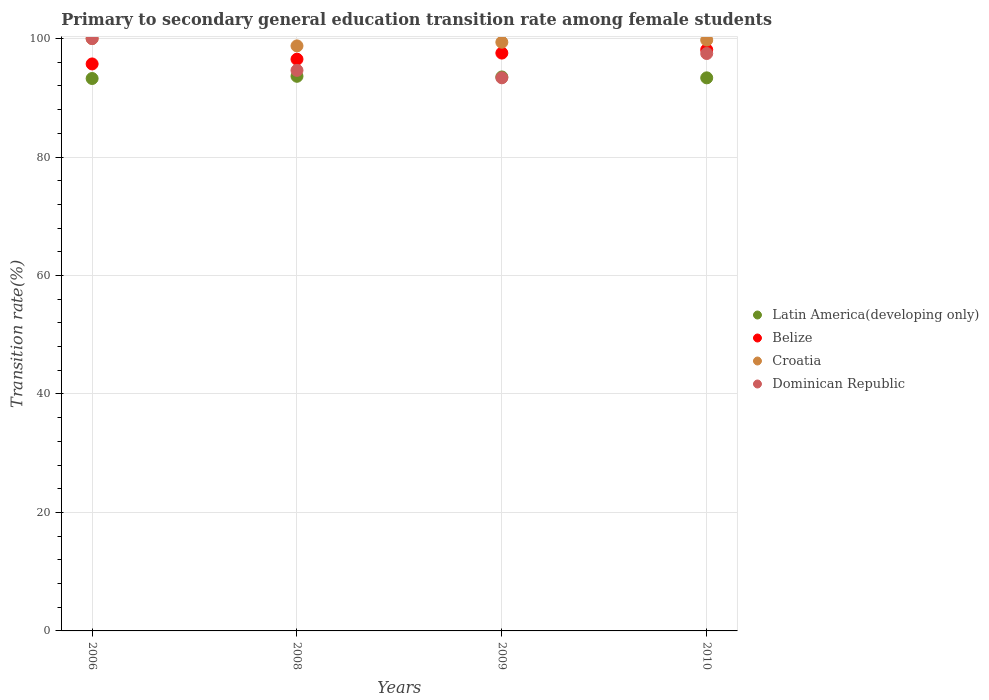What is the transition rate in Croatia in 2010?
Give a very brief answer. 99.75. Across all years, what is the maximum transition rate in Croatia?
Your answer should be compact. 100. Across all years, what is the minimum transition rate in Dominican Republic?
Give a very brief answer. 93.38. In which year was the transition rate in Dominican Republic minimum?
Your answer should be very brief. 2009. What is the total transition rate in Belize in the graph?
Offer a terse response. 387.91. What is the difference between the transition rate in Belize in 2006 and that in 2008?
Provide a succinct answer. -0.8. What is the difference between the transition rate in Dominican Republic in 2006 and the transition rate in Belize in 2008?
Provide a succinct answer. 3.48. What is the average transition rate in Belize per year?
Your answer should be compact. 96.98. In the year 2010, what is the difference between the transition rate in Latin America(developing only) and transition rate in Croatia?
Give a very brief answer. -6.38. What is the ratio of the transition rate in Latin America(developing only) in 2006 to that in 2010?
Keep it short and to the point. 1. Is the difference between the transition rate in Latin America(developing only) in 2006 and 2009 greater than the difference between the transition rate in Croatia in 2006 and 2009?
Provide a short and direct response. No. What is the difference between the highest and the second highest transition rate in Croatia?
Give a very brief answer. 0.25. What is the difference between the highest and the lowest transition rate in Croatia?
Make the answer very short. 1.23. In how many years, is the transition rate in Croatia greater than the average transition rate in Croatia taken over all years?
Keep it short and to the point. 2. Is it the case that in every year, the sum of the transition rate in Croatia and transition rate in Dominican Republic  is greater than the sum of transition rate in Belize and transition rate in Latin America(developing only)?
Offer a very short reply. No. Is it the case that in every year, the sum of the transition rate in Belize and transition rate in Latin America(developing only)  is greater than the transition rate in Dominican Republic?
Offer a terse response. Yes. Is the transition rate in Belize strictly less than the transition rate in Latin America(developing only) over the years?
Give a very brief answer. No. How many years are there in the graph?
Give a very brief answer. 4. Are the values on the major ticks of Y-axis written in scientific E-notation?
Your answer should be compact. No. Where does the legend appear in the graph?
Ensure brevity in your answer.  Center right. What is the title of the graph?
Your response must be concise. Primary to secondary general education transition rate among female students. What is the label or title of the X-axis?
Offer a very short reply. Years. What is the label or title of the Y-axis?
Offer a very short reply. Transition rate(%). What is the Transition rate(%) in Latin America(developing only) in 2006?
Your answer should be compact. 93.26. What is the Transition rate(%) in Belize in 2006?
Give a very brief answer. 95.72. What is the Transition rate(%) in Croatia in 2006?
Give a very brief answer. 100. What is the Transition rate(%) in Dominican Republic in 2006?
Offer a very short reply. 100. What is the Transition rate(%) of Latin America(developing only) in 2008?
Make the answer very short. 93.63. What is the Transition rate(%) in Belize in 2008?
Ensure brevity in your answer.  96.52. What is the Transition rate(%) of Croatia in 2008?
Give a very brief answer. 98.77. What is the Transition rate(%) in Dominican Republic in 2008?
Offer a very short reply. 94.63. What is the Transition rate(%) of Latin America(developing only) in 2009?
Provide a short and direct response. 93.52. What is the Transition rate(%) of Belize in 2009?
Make the answer very short. 97.55. What is the Transition rate(%) in Croatia in 2009?
Keep it short and to the point. 99.38. What is the Transition rate(%) of Dominican Republic in 2009?
Provide a succinct answer. 93.38. What is the Transition rate(%) in Latin America(developing only) in 2010?
Offer a terse response. 93.37. What is the Transition rate(%) of Belize in 2010?
Your answer should be compact. 98.12. What is the Transition rate(%) in Croatia in 2010?
Ensure brevity in your answer.  99.75. What is the Transition rate(%) in Dominican Republic in 2010?
Provide a succinct answer. 97.48. Across all years, what is the maximum Transition rate(%) of Latin America(developing only)?
Offer a terse response. 93.63. Across all years, what is the maximum Transition rate(%) in Belize?
Provide a short and direct response. 98.12. Across all years, what is the maximum Transition rate(%) of Croatia?
Ensure brevity in your answer.  100. Across all years, what is the minimum Transition rate(%) of Latin America(developing only)?
Keep it short and to the point. 93.26. Across all years, what is the minimum Transition rate(%) in Belize?
Your answer should be compact. 95.72. Across all years, what is the minimum Transition rate(%) in Croatia?
Keep it short and to the point. 98.77. Across all years, what is the minimum Transition rate(%) in Dominican Republic?
Provide a succinct answer. 93.38. What is the total Transition rate(%) of Latin America(developing only) in the graph?
Offer a very short reply. 373.78. What is the total Transition rate(%) in Belize in the graph?
Your answer should be compact. 387.91. What is the total Transition rate(%) in Croatia in the graph?
Keep it short and to the point. 397.9. What is the total Transition rate(%) of Dominican Republic in the graph?
Give a very brief answer. 385.49. What is the difference between the Transition rate(%) in Latin America(developing only) in 2006 and that in 2008?
Make the answer very short. -0.37. What is the difference between the Transition rate(%) of Belize in 2006 and that in 2008?
Provide a succinct answer. -0.8. What is the difference between the Transition rate(%) of Croatia in 2006 and that in 2008?
Give a very brief answer. 1.24. What is the difference between the Transition rate(%) of Dominican Republic in 2006 and that in 2008?
Make the answer very short. 5.37. What is the difference between the Transition rate(%) in Latin America(developing only) in 2006 and that in 2009?
Offer a very short reply. -0.26. What is the difference between the Transition rate(%) of Belize in 2006 and that in 2009?
Your answer should be very brief. -1.83. What is the difference between the Transition rate(%) in Croatia in 2006 and that in 2009?
Ensure brevity in your answer.  0.62. What is the difference between the Transition rate(%) in Dominican Republic in 2006 and that in 2009?
Your answer should be compact. 6.62. What is the difference between the Transition rate(%) in Latin America(developing only) in 2006 and that in 2010?
Your response must be concise. -0.11. What is the difference between the Transition rate(%) in Belize in 2006 and that in 2010?
Offer a terse response. -2.4. What is the difference between the Transition rate(%) of Croatia in 2006 and that in 2010?
Ensure brevity in your answer.  0.25. What is the difference between the Transition rate(%) of Dominican Republic in 2006 and that in 2010?
Ensure brevity in your answer.  2.52. What is the difference between the Transition rate(%) of Latin America(developing only) in 2008 and that in 2009?
Ensure brevity in your answer.  0.11. What is the difference between the Transition rate(%) in Belize in 2008 and that in 2009?
Your answer should be very brief. -1.03. What is the difference between the Transition rate(%) in Croatia in 2008 and that in 2009?
Ensure brevity in your answer.  -0.62. What is the difference between the Transition rate(%) of Dominican Republic in 2008 and that in 2009?
Keep it short and to the point. 1.26. What is the difference between the Transition rate(%) of Latin America(developing only) in 2008 and that in 2010?
Ensure brevity in your answer.  0.26. What is the difference between the Transition rate(%) of Belize in 2008 and that in 2010?
Keep it short and to the point. -1.6. What is the difference between the Transition rate(%) of Croatia in 2008 and that in 2010?
Provide a succinct answer. -0.99. What is the difference between the Transition rate(%) of Dominican Republic in 2008 and that in 2010?
Provide a short and direct response. -2.84. What is the difference between the Transition rate(%) in Latin America(developing only) in 2009 and that in 2010?
Your answer should be compact. 0.15. What is the difference between the Transition rate(%) of Belize in 2009 and that in 2010?
Provide a succinct answer. -0.57. What is the difference between the Transition rate(%) of Croatia in 2009 and that in 2010?
Provide a short and direct response. -0.37. What is the difference between the Transition rate(%) of Dominican Republic in 2009 and that in 2010?
Your answer should be compact. -4.1. What is the difference between the Transition rate(%) of Latin America(developing only) in 2006 and the Transition rate(%) of Belize in 2008?
Your answer should be very brief. -3.26. What is the difference between the Transition rate(%) of Latin America(developing only) in 2006 and the Transition rate(%) of Croatia in 2008?
Make the answer very short. -5.51. What is the difference between the Transition rate(%) of Latin America(developing only) in 2006 and the Transition rate(%) of Dominican Republic in 2008?
Your answer should be very brief. -1.38. What is the difference between the Transition rate(%) in Belize in 2006 and the Transition rate(%) in Croatia in 2008?
Give a very brief answer. -3.05. What is the difference between the Transition rate(%) of Belize in 2006 and the Transition rate(%) of Dominican Republic in 2008?
Your answer should be very brief. 1.08. What is the difference between the Transition rate(%) of Croatia in 2006 and the Transition rate(%) of Dominican Republic in 2008?
Make the answer very short. 5.37. What is the difference between the Transition rate(%) in Latin America(developing only) in 2006 and the Transition rate(%) in Belize in 2009?
Provide a succinct answer. -4.29. What is the difference between the Transition rate(%) of Latin America(developing only) in 2006 and the Transition rate(%) of Croatia in 2009?
Offer a terse response. -6.12. What is the difference between the Transition rate(%) of Latin America(developing only) in 2006 and the Transition rate(%) of Dominican Republic in 2009?
Offer a very short reply. -0.12. What is the difference between the Transition rate(%) of Belize in 2006 and the Transition rate(%) of Croatia in 2009?
Offer a very short reply. -3.66. What is the difference between the Transition rate(%) in Belize in 2006 and the Transition rate(%) in Dominican Republic in 2009?
Your answer should be compact. 2.34. What is the difference between the Transition rate(%) of Croatia in 2006 and the Transition rate(%) of Dominican Republic in 2009?
Offer a terse response. 6.62. What is the difference between the Transition rate(%) in Latin America(developing only) in 2006 and the Transition rate(%) in Belize in 2010?
Give a very brief answer. -4.86. What is the difference between the Transition rate(%) in Latin America(developing only) in 2006 and the Transition rate(%) in Croatia in 2010?
Make the answer very short. -6.49. What is the difference between the Transition rate(%) of Latin America(developing only) in 2006 and the Transition rate(%) of Dominican Republic in 2010?
Offer a terse response. -4.22. What is the difference between the Transition rate(%) of Belize in 2006 and the Transition rate(%) of Croatia in 2010?
Offer a very short reply. -4.04. What is the difference between the Transition rate(%) of Belize in 2006 and the Transition rate(%) of Dominican Republic in 2010?
Provide a succinct answer. -1.76. What is the difference between the Transition rate(%) in Croatia in 2006 and the Transition rate(%) in Dominican Republic in 2010?
Your response must be concise. 2.52. What is the difference between the Transition rate(%) in Latin America(developing only) in 2008 and the Transition rate(%) in Belize in 2009?
Your response must be concise. -3.92. What is the difference between the Transition rate(%) in Latin America(developing only) in 2008 and the Transition rate(%) in Croatia in 2009?
Your answer should be very brief. -5.75. What is the difference between the Transition rate(%) in Latin America(developing only) in 2008 and the Transition rate(%) in Dominican Republic in 2009?
Give a very brief answer. 0.26. What is the difference between the Transition rate(%) of Belize in 2008 and the Transition rate(%) of Croatia in 2009?
Your answer should be very brief. -2.86. What is the difference between the Transition rate(%) in Belize in 2008 and the Transition rate(%) in Dominican Republic in 2009?
Your answer should be compact. 3.14. What is the difference between the Transition rate(%) of Croatia in 2008 and the Transition rate(%) of Dominican Republic in 2009?
Ensure brevity in your answer.  5.39. What is the difference between the Transition rate(%) of Latin America(developing only) in 2008 and the Transition rate(%) of Belize in 2010?
Offer a terse response. -4.49. What is the difference between the Transition rate(%) of Latin America(developing only) in 2008 and the Transition rate(%) of Croatia in 2010?
Your answer should be compact. -6.12. What is the difference between the Transition rate(%) in Latin America(developing only) in 2008 and the Transition rate(%) in Dominican Republic in 2010?
Keep it short and to the point. -3.85. What is the difference between the Transition rate(%) of Belize in 2008 and the Transition rate(%) of Croatia in 2010?
Offer a terse response. -3.23. What is the difference between the Transition rate(%) of Belize in 2008 and the Transition rate(%) of Dominican Republic in 2010?
Make the answer very short. -0.96. What is the difference between the Transition rate(%) in Croatia in 2008 and the Transition rate(%) in Dominican Republic in 2010?
Ensure brevity in your answer.  1.29. What is the difference between the Transition rate(%) of Latin America(developing only) in 2009 and the Transition rate(%) of Belize in 2010?
Make the answer very short. -4.6. What is the difference between the Transition rate(%) of Latin America(developing only) in 2009 and the Transition rate(%) of Croatia in 2010?
Make the answer very short. -6.23. What is the difference between the Transition rate(%) in Latin America(developing only) in 2009 and the Transition rate(%) in Dominican Republic in 2010?
Your response must be concise. -3.96. What is the difference between the Transition rate(%) in Belize in 2009 and the Transition rate(%) in Croatia in 2010?
Keep it short and to the point. -2.2. What is the difference between the Transition rate(%) of Belize in 2009 and the Transition rate(%) of Dominican Republic in 2010?
Make the answer very short. 0.07. What is the difference between the Transition rate(%) of Croatia in 2009 and the Transition rate(%) of Dominican Republic in 2010?
Offer a terse response. 1.9. What is the average Transition rate(%) of Latin America(developing only) per year?
Ensure brevity in your answer.  93.44. What is the average Transition rate(%) of Belize per year?
Give a very brief answer. 96.98. What is the average Transition rate(%) in Croatia per year?
Your answer should be very brief. 99.47. What is the average Transition rate(%) in Dominican Republic per year?
Make the answer very short. 96.37. In the year 2006, what is the difference between the Transition rate(%) in Latin America(developing only) and Transition rate(%) in Belize?
Keep it short and to the point. -2.46. In the year 2006, what is the difference between the Transition rate(%) of Latin America(developing only) and Transition rate(%) of Croatia?
Offer a terse response. -6.74. In the year 2006, what is the difference between the Transition rate(%) of Latin America(developing only) and Transition rate(%) of Dominican Republic?
Your answer should be compact. -6.74. In the year 2006, what is the difference between the Transition rate(%) of Belize and Transition rate(%) of Croatia?
Offer a very short reply. -4.28. In the year 2006, what is the difference between the Transition rate(%) of Belize and Transition rate(%) of Dominican Republic?
Your answer should be compact. -4.28. In the year 2006, what is the difference between the Transition rate(%) of Croatia and Transition rate(%) of Dominican Republic?
Offer a terse response. 0. In the year 2008, what is the difference between the Transition rate(%) of Latin America(developing only) and Transition rate(%) of Belize?
Provide a succinct answer. -2.89. In the year 2008, what is the difference between the Transition rate(%) of Latin America(developing only) and Transition rate(%) of Croatia?
Give a very brief answer. -5.13. In the year 2008, what is the difference between the Transition rate(%) in Latin America(developing only) and Transition rate(%) in Dominican Republic?
Offer a very short reply. -1. In the year 2008, what is the difference between the Transition rate(%) in Belize and Transition rate(%) in Croatia?
Offer a terse response. -2.25. In the year 2008, what is the difference between the Transition rate(%) in Belize and Transition rate(%) in Dominican Republic?
Provide a succinct answer. 1.89. In the year 2008, what is the difference between the Transition rate(%) in Croatia and Transition rate(%) in Dominican Republic?
Make the answer very short. 4.13. In the year 2009, what is the difference between the Transition rate(%) in Latin America(developing only) and Transition rate(%) in Belize?
Your response must be concise. -4.03. In the year 2009, what is the difference between the Transition rate(%) in Latin America(developing only) and Transition rate(%) in Croatia?
Keep it short and to the point. -5.86. In the year 2009, what is the difference between the Transition rate(%) of Latin America(developing only) and Transition rate(%) of Dominican Republic?
Offer a terse response. 0.14. In the year 2009, what is the difference between the Transition rate(%) of Belize and Transition rate(%) of Croatia?
Ensure brevity in your answer.  -1.83. In the year 2009, what is the difference between the Transition rate(%) of Belize and Transition rate(%) of Dominican Republic?
Your response must be concise. 4.17. In the year 2009, what is the difference between the Transition rate(%) in Croatia and Transition rate(%) in Dominican Republic?
Keep it short and to the point. 6. In the year 2010, what is the difference between the Transition rate(%) in Latin America(developing only) and Transition rate(%) in Belize?
Ensure brevity in your answer.  -4.75. In the year 2010, what is the difference between the Transition rate(%) in Latin America(developing only) and Transition rate(%) in Croatia?
Make the answer very short. -6.38. In the year 2010, what is the difference between the Transition rate(%) of Latin America(developing only) and Transition rate(%) of Dominican Republic?
Give a very brief answer. -4.11. In the year 2010, what is the difference between the Transition rate(%) of Belize and Transition rate(%) of Croatia?
Make the answer very short. -1.63. In the year 2010, what is the difference between the Transition rate(%) in Belize and Transition rate(%) in Dominican Republic?
Ensure brevity in your answer.  0.64. In the year 2010, what is the difference between the Transition rate(%) of Croatia and Transition rate(%) of Dominican Republic?
Make the answer very short. 2.27. What is the ratio of the Transition rate(%) in Latin America(developing only) in 2006 to that in 2008?
Provide a short and direct response. 1. What is the ratio of the Transition rate(%) in Croatia in 2006 to that in 2008?
Offer a very short reply. 1.01. What is the ratio of the Transition rate(%) in Dominican Republic in 2006 to that in 2008?
Keep it short and to the point. 1.06. What is the ratio of the Transition rate(%) in Belize in 2006 to that in 2009?
Your answer should be compact. 0.98. What is the ratio of the Transition rate(%) in Dominican Republic in 2006 to that in 2009?
Your answer should be very brief. 1.07. What is the ratio of the Transition rate(%) of Latin America(developing only) in 2006 to that in 2010?
Provide a succinct answer. 1. What is the ratio of the Transition rate(%) of Belize in 2006 to that in 2010?
Provide a short and direct response. 0.98. What is the ratio of the Transition rate(%) of Croatia in 2006 to that in 2010?
Make the answer very short. 1. What is the ratio of the Transition rate(%) of Dominican Republic in 2006 to that in 2010?
Give a very brief answer. 1.03. What is the ratio of the Transition rate(%) of Dominican Republic in 2008 to that in 2009?
Offer a very short reply. 1.01. What is the ratio of the Transition rate(%) of Belize in 2008 to that in 2010?
Offer a terse response. 0.98. What is the ratio of the Transition rate(%) in Dominican Republic in 2008 to that in 2010?
Offer a terse response. 0.97. What is the ratio of the Transition rate(%) in Latin America(developing only) in 2009 to that in 2010?
Ensure brevity in your answer.  1. What is the ratio of the Transition rate(%) in Belize in 2009 to that in 2010?
Give a very brief answer. 0.99. What is the ratio of the Transition rate(%) in Dominican Republic in 2009 to that in 2010?
Keep it short and to the point. 0.96. What is the difference between the highest and the second highest Transition rate(%) in Latin America(developing only)?
Keep it short and to the point. 0.11. What is the difference between the highest and the second highest Transition rate(%) of Belize?
Your answer should be compact. 0.57. What is the difference between the highest and the second highest Transition rate(%) in Croatia?
Your answer should be very brief. 0.25. What is the difference between the highest and the second highest Transition rate(%) in Dominican Republic?
Offer a terse response. 2.52. What is the difference between the highest and the lowest Transition rate(%) of Latin America(developing only)?
Keep it short and to the point. 0.37. What is the difference between the highest and the lowest Transition rate(%) of Belize?
Provide a succinct answer. 2.4. What is the difference between the highest and the lowest Transition rate(%) of Croatia?
Offer a terse response. 1.24. What is the difference between the highest and the lowest Transition rate(%) in Dominican Republic?
Provide a succinct answer. 6.62. 